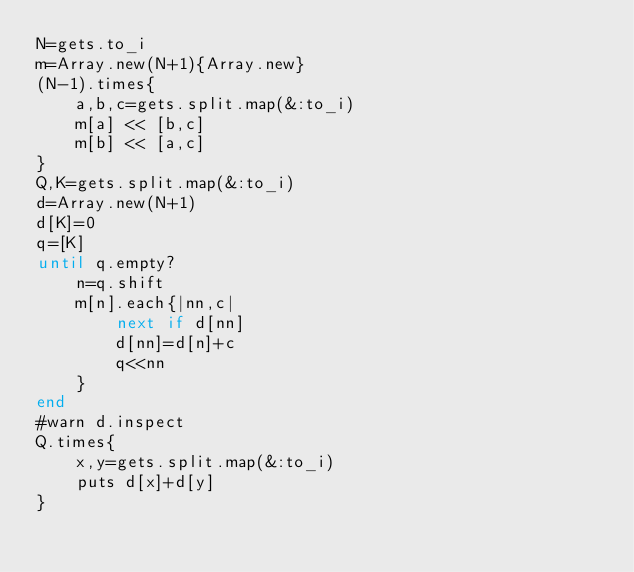Convert code to text. <code><loc_0><loc_0><loc_500><loc_500><_Ruby_>N=gets.to_i
m=Array.new(N+1){Array.new}
(N-1).times{
    a,b,c=gets.split.map(&:to_i)
    m[a] << [b,c]
    m[b] << [a,c]
}
Q,K=gets.split.map(&:to_i)
d=Array.new(N+1)
d[K]=0
q=[K]
until q.empty?
    n=q.shift
    m[n].each{|nn,c|
        next if d[nn]
        d[nn]=d[n]+c
        q<<nn
    }
end
#warn d.inspect
Q.times{
    x,y=gets.split.map(&:to_i)
    puts d[x]+d[y]
}
</code> 